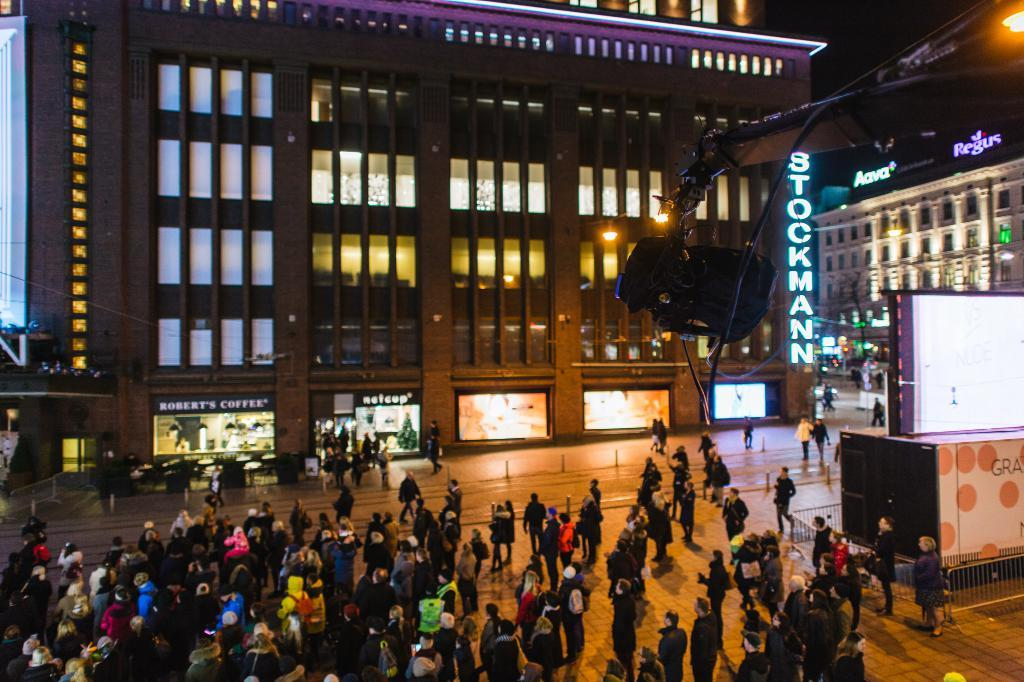<image>
Describe the image concisely. the name Robert's Coffee is on a restaurant 